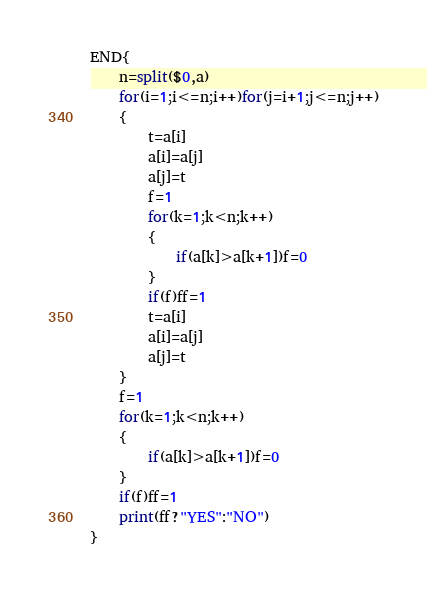<code> <loc_0><loc_0><loc_500><loc_500><_Awk_>END{
	n=split($0,a)
	for(i=1;i<=n;i++)for(j=i+1;j<=n;j++)
	{
		t=a[i]
		a[i]=a[j]
		a[j]=t
		f=1
		for(k=1;k<n;k++)
		{
			if(a[k]>a[k+1])f=0
		}
		if(f)ff=1
		t=a[i]
		a[i]=a[j]
		a[j]=t
	}
    f=1
	for(k=1;k<n;k++)
	{
		if(a[k]>a[k+1])f=0
	}
	if(f)ff=1
	print(ff?"YES":"NO")
}</code> 